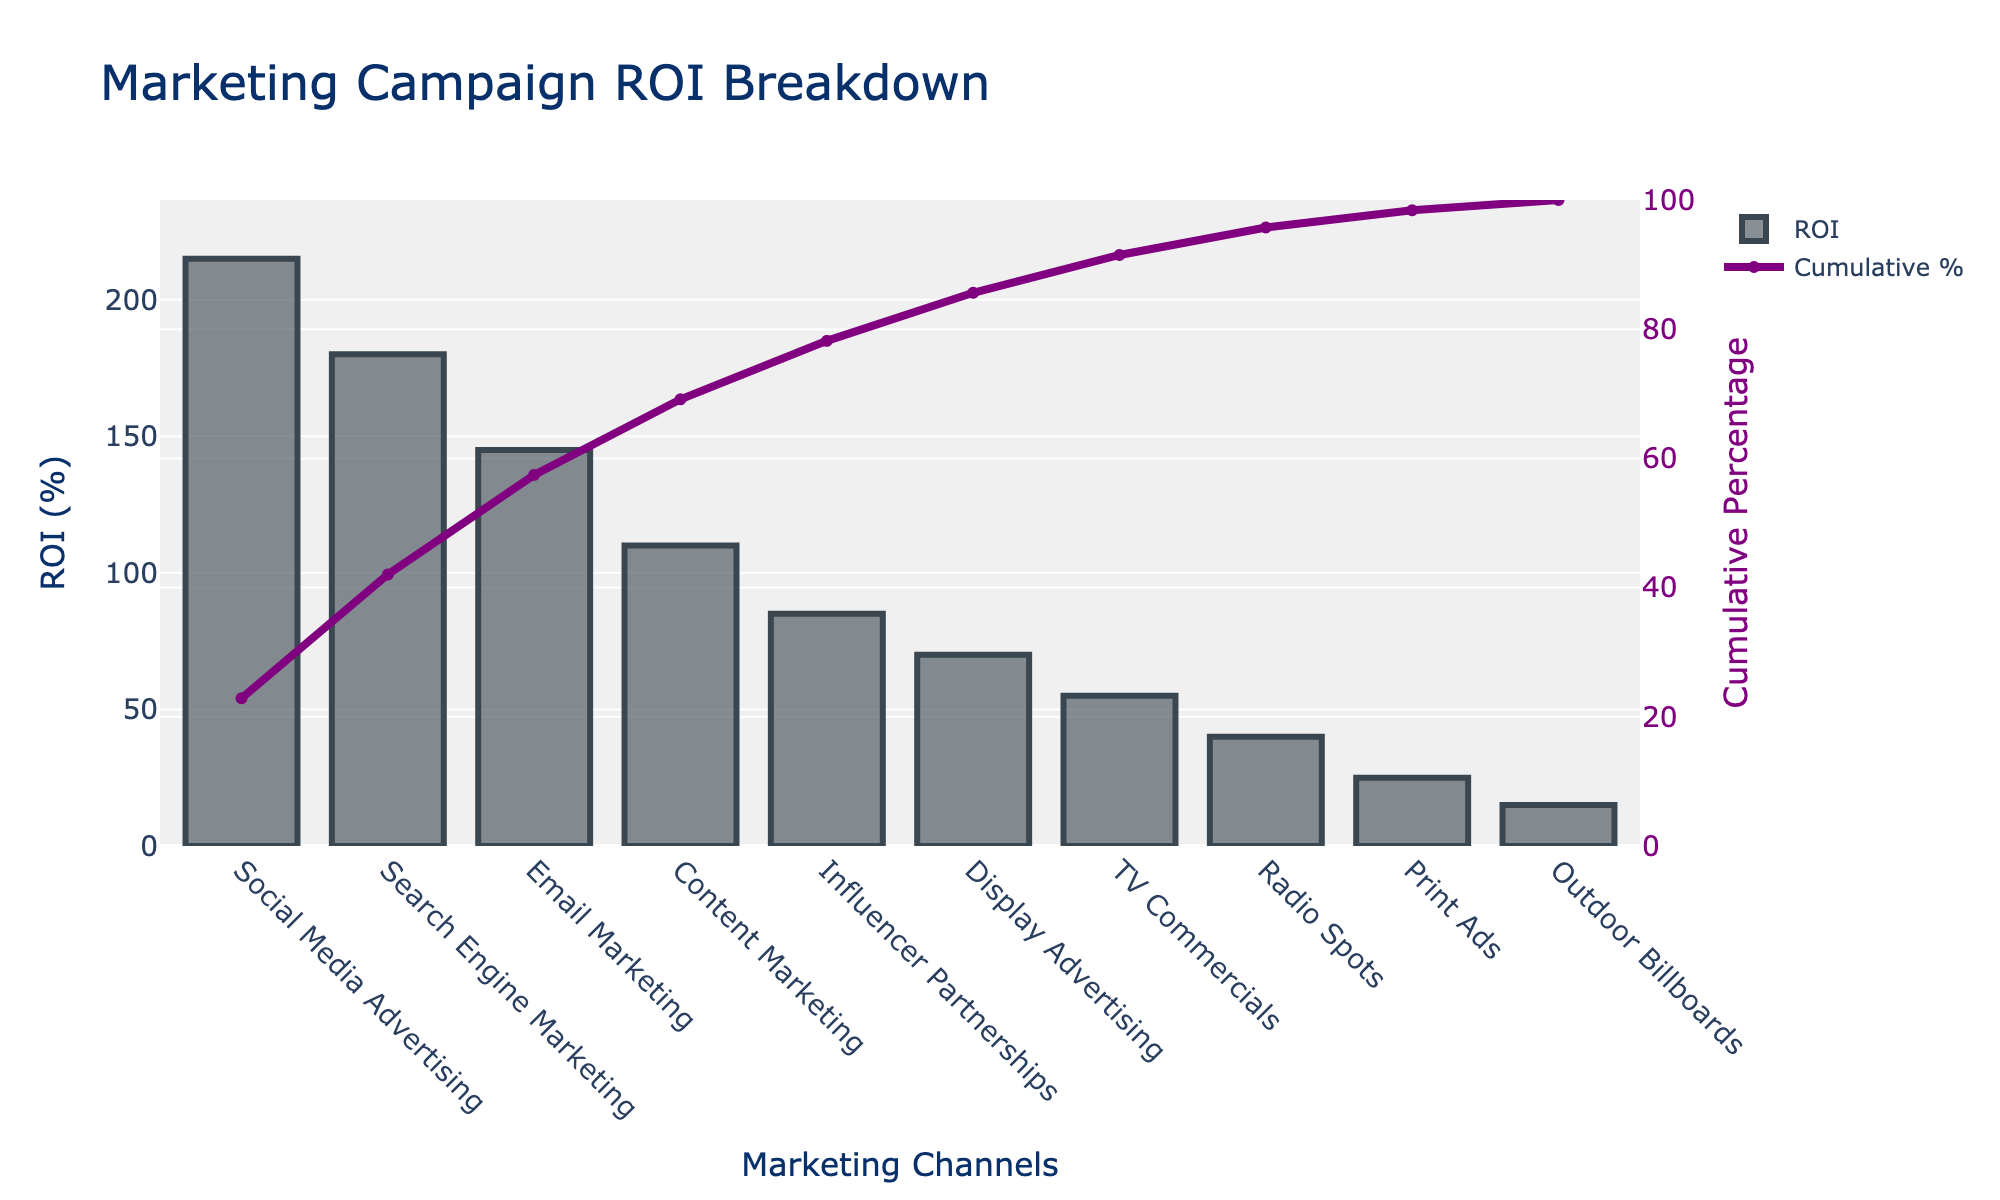What's the title of the figure? The title is at the top of the chart in larger font size. It provides a summary of what the chart represents.
Answer: Marketing Campaign ROI Breakdown What is the ROI (%) for Search Engine Marketing? Find the bar labeled 'Search Engine Marketing' along the x-axis and check its height on the y-axis to determine its ROI percentage.
Answer: 180% Which channel has the lowest ROI, and what is its value? Look for the shortest bar on the chart and identify the label on the x-axis.
Answer: Outdoor Billboards, 15% How many channels have an ROI (%) greater than 100%? Count the number of bars that extend above the 100% mark on the y-axis.
Answer: 3 What percentage of the total ROI is contributed by the top three channels? Sum the ROI values of the top three channels and divide by the total ROI, then multiply by 100: (215 + 180 + 145) / (total ROI) * 100
Answer: 64.3% Which channel's cumulative percentage first exceeds 50%? Identify the point on the Cumulative % line that first surpasses 50% on the right y-axis and check its corresponding channel.
Answer: Email Marketing Compare the ROI (%) of Social Media Advertising and TV Commercials. Which is higher and by how much? Subtract the ROI value of TV Commercials from that of Social Media Advertising: 215% - 55%
Answer: Social Media Advertising is higher by 160% What is the cumulative percentage at the point where Email Marketing is considered? Look at the cumulative percentage curve and note the value when it aligns with Email Marketing on the x-axis.
Answer: 54% Is the cumulative percentage for Display Advertising above 80%? Check the value of the cumulative percentage line corresponding to Display Advertising on the x-axis.
Answer: No, it is below 80% What is the difference in ROI between Content Marketing and Influencer Partnerships? Subtract the ROI value of Influencer Partnerships from that of Content Marketing: 110% - 85%
Answer: 25% 